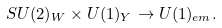<formula> <loc_0><loc_0><loc_500><loc_500>S U ( 2 ) _ { W } \times U ( 1 ) _ { Y } \to U ( 1 ) _ { e m } .</formula> 